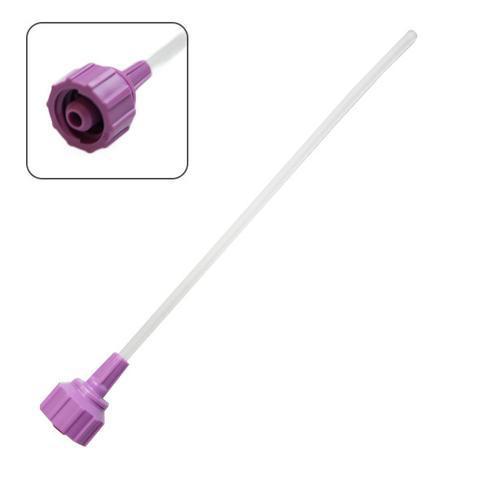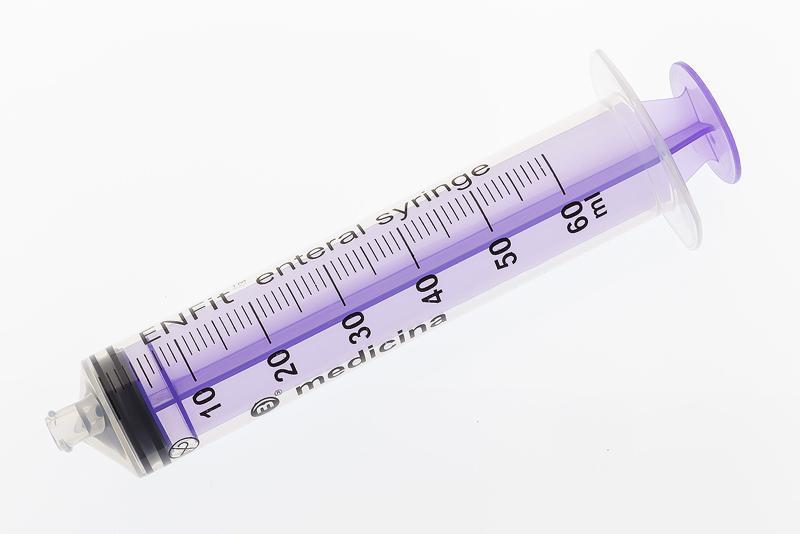The first image is the image on the left, the second image is the image on the right. For the images shown, is this caption "The syringe is marked to contain up to 60ml." true? Answer yes or no. Yes. The first image is the image on the left, the second image is the image on the right. Evaluate the accuracy of this statement regarding the images: "There is one purple syringe and one metal tool all sideways with the right side up.". Is it true? Answer yes or no. No. 